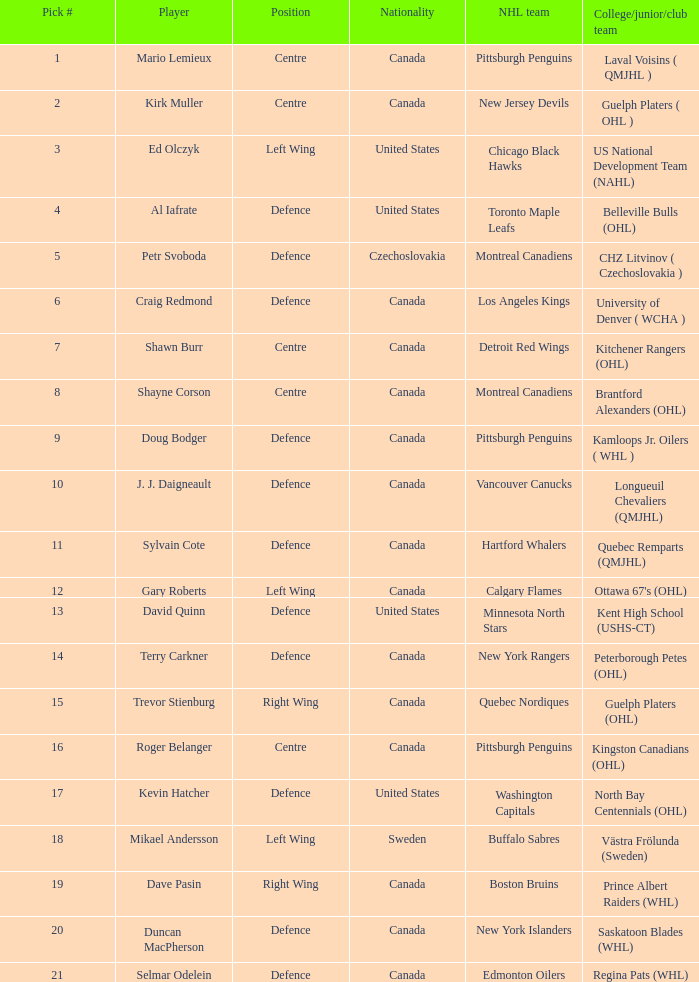What nationality is the draft pick player going to Minnesota North Stars? United States. 